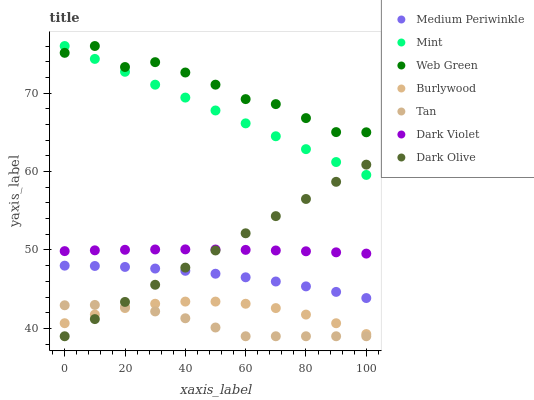Does Tan have the minimum area under the curve?
Answer yes or no. Yes. Does Web Green have the maximum area under the curve?
Answer yes or no. Yes. Does Dark Olive have the minimum area under the curve?
Answer yes or no. No. Does Dark Olive have the maximum area under the curve?
Answer yes or no. No. Is Dark Olive the smoothest?
Answer yes or no. Yes. Is Web Green the roughest?
Answer yes or no. Yes. Is Medium Periwinkle the smoothest?
Answer yes or no. No. Is Medium Periwinkle the roughest?
Answer yes or no. No. Does Dark Olive have the lowest value?
Answer yes or no. Yes. Does Medium Periwinkle have the lowest value?
Answer yes or no. No. Does Mint have the highest value?
Answer yes or no. Yes. Does Dark Olive have the highest value?
Answer yes or no. No. Is Medium Periwinkle less than Web Green?
Answer yes or no. Yes. Is Medium Periwinkle greater than Tan?
Answer yes or no. Yes. Does Dark Olive intersect Medium Periwinkle?
Answer yes or no. Yes. Is Dark Olive less than Medium Periwinkle?
Answer yes or no. No. Is Dark Olive greater than Medium Periwinkle?
Answer yes or no. No. Does Medium Periwinkle intersect Web Green?
Answer yes or no. No. 